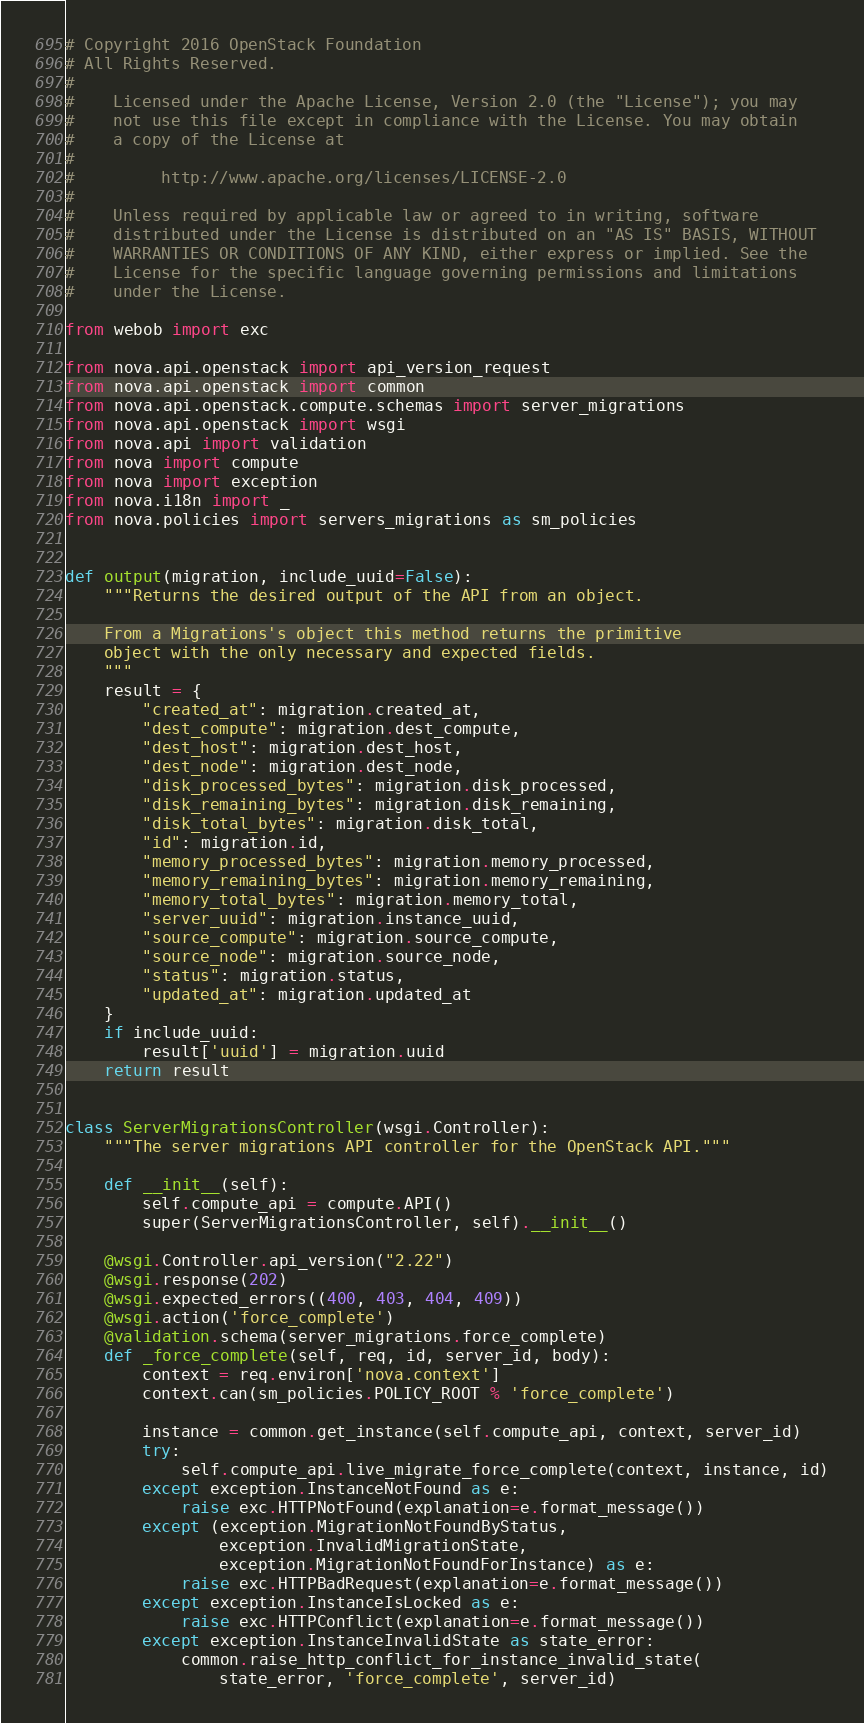Convert code to text. <code><loc_0><loc_0><loc_500><loc_500><_Python_># Copyright 2016 OpenStack Foundation
# All Rights Reserved.
#
#    Licensed under the Apache License, Version 2.0 (the "License"); you may
#    not use this file except in compliance with the License. You may obtain
#    a copy of the License at
#
#         http://www.apache.org/licenses/LICENSE-2.0
#
#    Unless required by applicable law or agreed to in writing, software
#    distributed under the License is distributed on an "AS IS" BASIS, WITHOUT
#    WARRANTIES OR CONDITIONS OF ANY KIND, either express or implied. See the
#    License for the specific language governing permissions and limitations
#    under the License.

from webob import exc

from nova.api.openstack import api_version_request
from nova.api.openstack import common
from nova.api.openstack.compute.schemas import server_migrations
from nova.api.openstack import wsgi
from nova.api import validation
from nova import compute
from nova import exception
from nova.i18n import _
from nova.policies import servers_migrations as sm_policies


def output(migration, include_uuid=False):
    """Returns the desired output of the API from an object.

    From a Migrations's object this method returns the primitive
    object with the only necessary and expected fields.
    """
    result = {
        "created_at": migration.created_at,
        "dest_compute": migration.dest_compute,
        "dest_host": migration.dest_host,
        "dest_node": migration.dest_node,
        "disk_processed_bytes": migration.disk_processed,
        "disk_remaining_bytes": migration.disk_remaining,
        "disk_total_bytes": migration.disk_total,
        "id": migration.id,
        "memory_processed_bytes": migration.memory_processed,
        "memory_remaining_bytes": migration.memory_remaining,
        "memory_total_bytes": migration.memory_total,
        "server_uuid": migration.instance_uuid,
        "source_compute": migration.source_compute,
        "source_node": migration.source_node,
        "status": migration.status,
        "updated_at": migration.updated_at
    }
    if include_uuid:
        result['uuid'] = migration.uuid
    return result


class ServerMigrationsController(wsgi.Controller):
    """The server migrations API controller for the OpenStack API."""

    def __init__(self):
        self.compute_api = compute.API()
        super(ServerMigrationsController, self).__init__()

    @wsgi.Controller.api_version("2.22")
    @wsgi.response(202)
    @wsgi.expected_errors((400, 403, 404, 409))
    @wsgi.action('force_complete')
    @validation.schema(server_migrations.force_complete)
    def _force_complete(self, req, id, server_id, body):
        context = req.environ['nova.context']
        context.can(sm_policies.POLICY_ROOT % 'force_complete')

        instance = common.get_instance(self.compute_api, context, server_id)
        try:
            self.compute_api.live_migrate_force_complete(context, instance, id)
        except exception.InstanceNotFound as e:
            raise exc.HTTPNotFound(explanation=e.format_message())
        except (exception.MigrationNotFoundByStatus,
                exception.InvalidMigrationState,
                exception.MigrationNotFoundForInstance) as e:
            raise exc.HTTPBadRequest(explanation=e.format_message())
        except exception.InstanceIsLocked as e:
            raise exc.HTTPConflict(explanation=e.format_message())
        except exception.InstanceInvalidState as state_error:
            common.raise_http_conflict_for_instance_invalid_state(
                state_error, 'force_complete', server_id)
</code> 